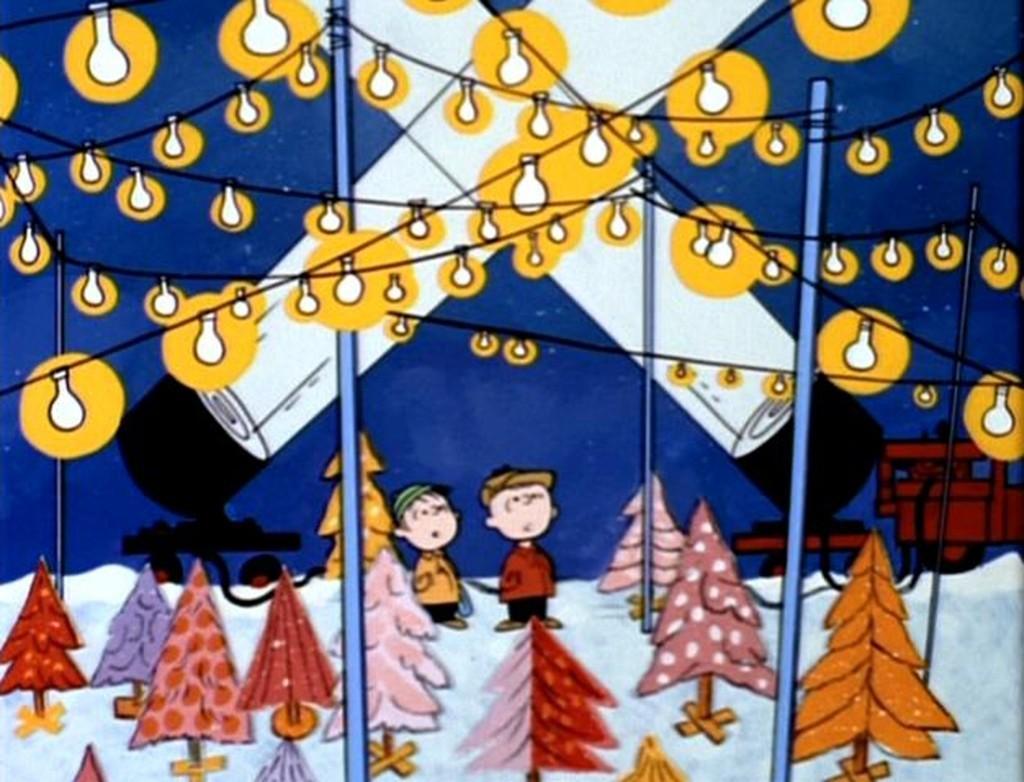Can you describe this image briefly? In this image we can see a cartoon picture. In the picture there are the electrical lights, flash lights, christmas trees, persons, motor vehicle and sky. 